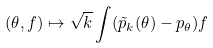<formula> <loc_0><loc_0><loc_500><loc_500>( \theta , f ) \mapsto \sqrt { k } \int ( \tilde { p } _ { k } ( \theta ) - p _ { \theta } ) f</formula> 